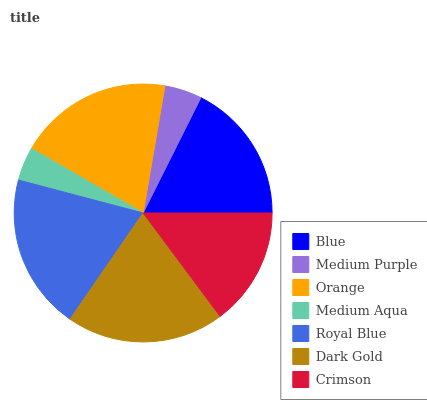Is Medium Aqua the minimum?
Answer yes or no. Yes. Is Dark Gold the maximum?
Answer yes or no. Yes. Is Medium Purple the minimum?
Answer yes or no. No. Is Medium Purple the maximum?
Answer yes or no. No. Is Blue greater than Medium Purple?
Answer yes or no. Yes. Is Medium Purple less than Blue?
Answer yes or no. Yes. Is Medium Purple greater than Blue?
Answer yes or no. No. Is Blue less than Medium Purple?
Answer yes or no. No. Is Blue the high median?
Answer yes or no. Yes. Is Blue the low median?
Answer yes or no. Yes. Is Royal Blue the high median?
Answer yes or no. No. Is Medium Aqua the low median?
Answer yes or no. No. 